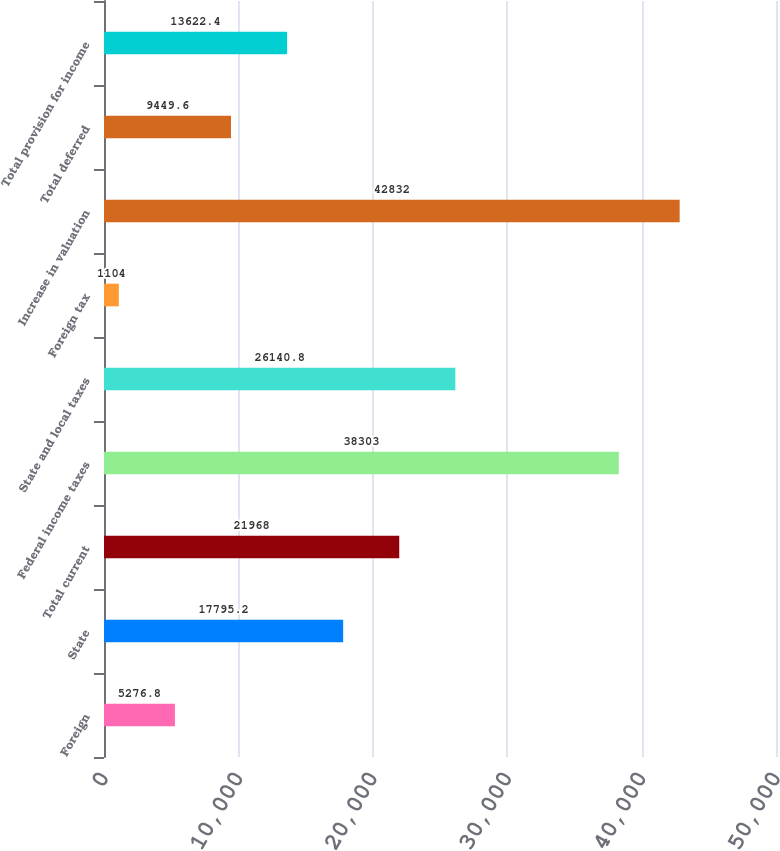<chart> <loc_0><loc_0><loc_500><loc_500><bar_chart><fcel>Foreign<fcel>State<fcel>Total current<fcel>Federal income taxes<fcel>State and local taxes<fcel>Foreign tax<fcel>Increase in valuation<fcel>Total deferred<fcel>Total provision for income<nl><fcel>5276.8<fcel>17795.2<fcel>21968<fcel>38303<fcel>26140.8<fcel>1104<fcel>42832<fcel>9449.6<fcel>13622.4<nl></chart> 